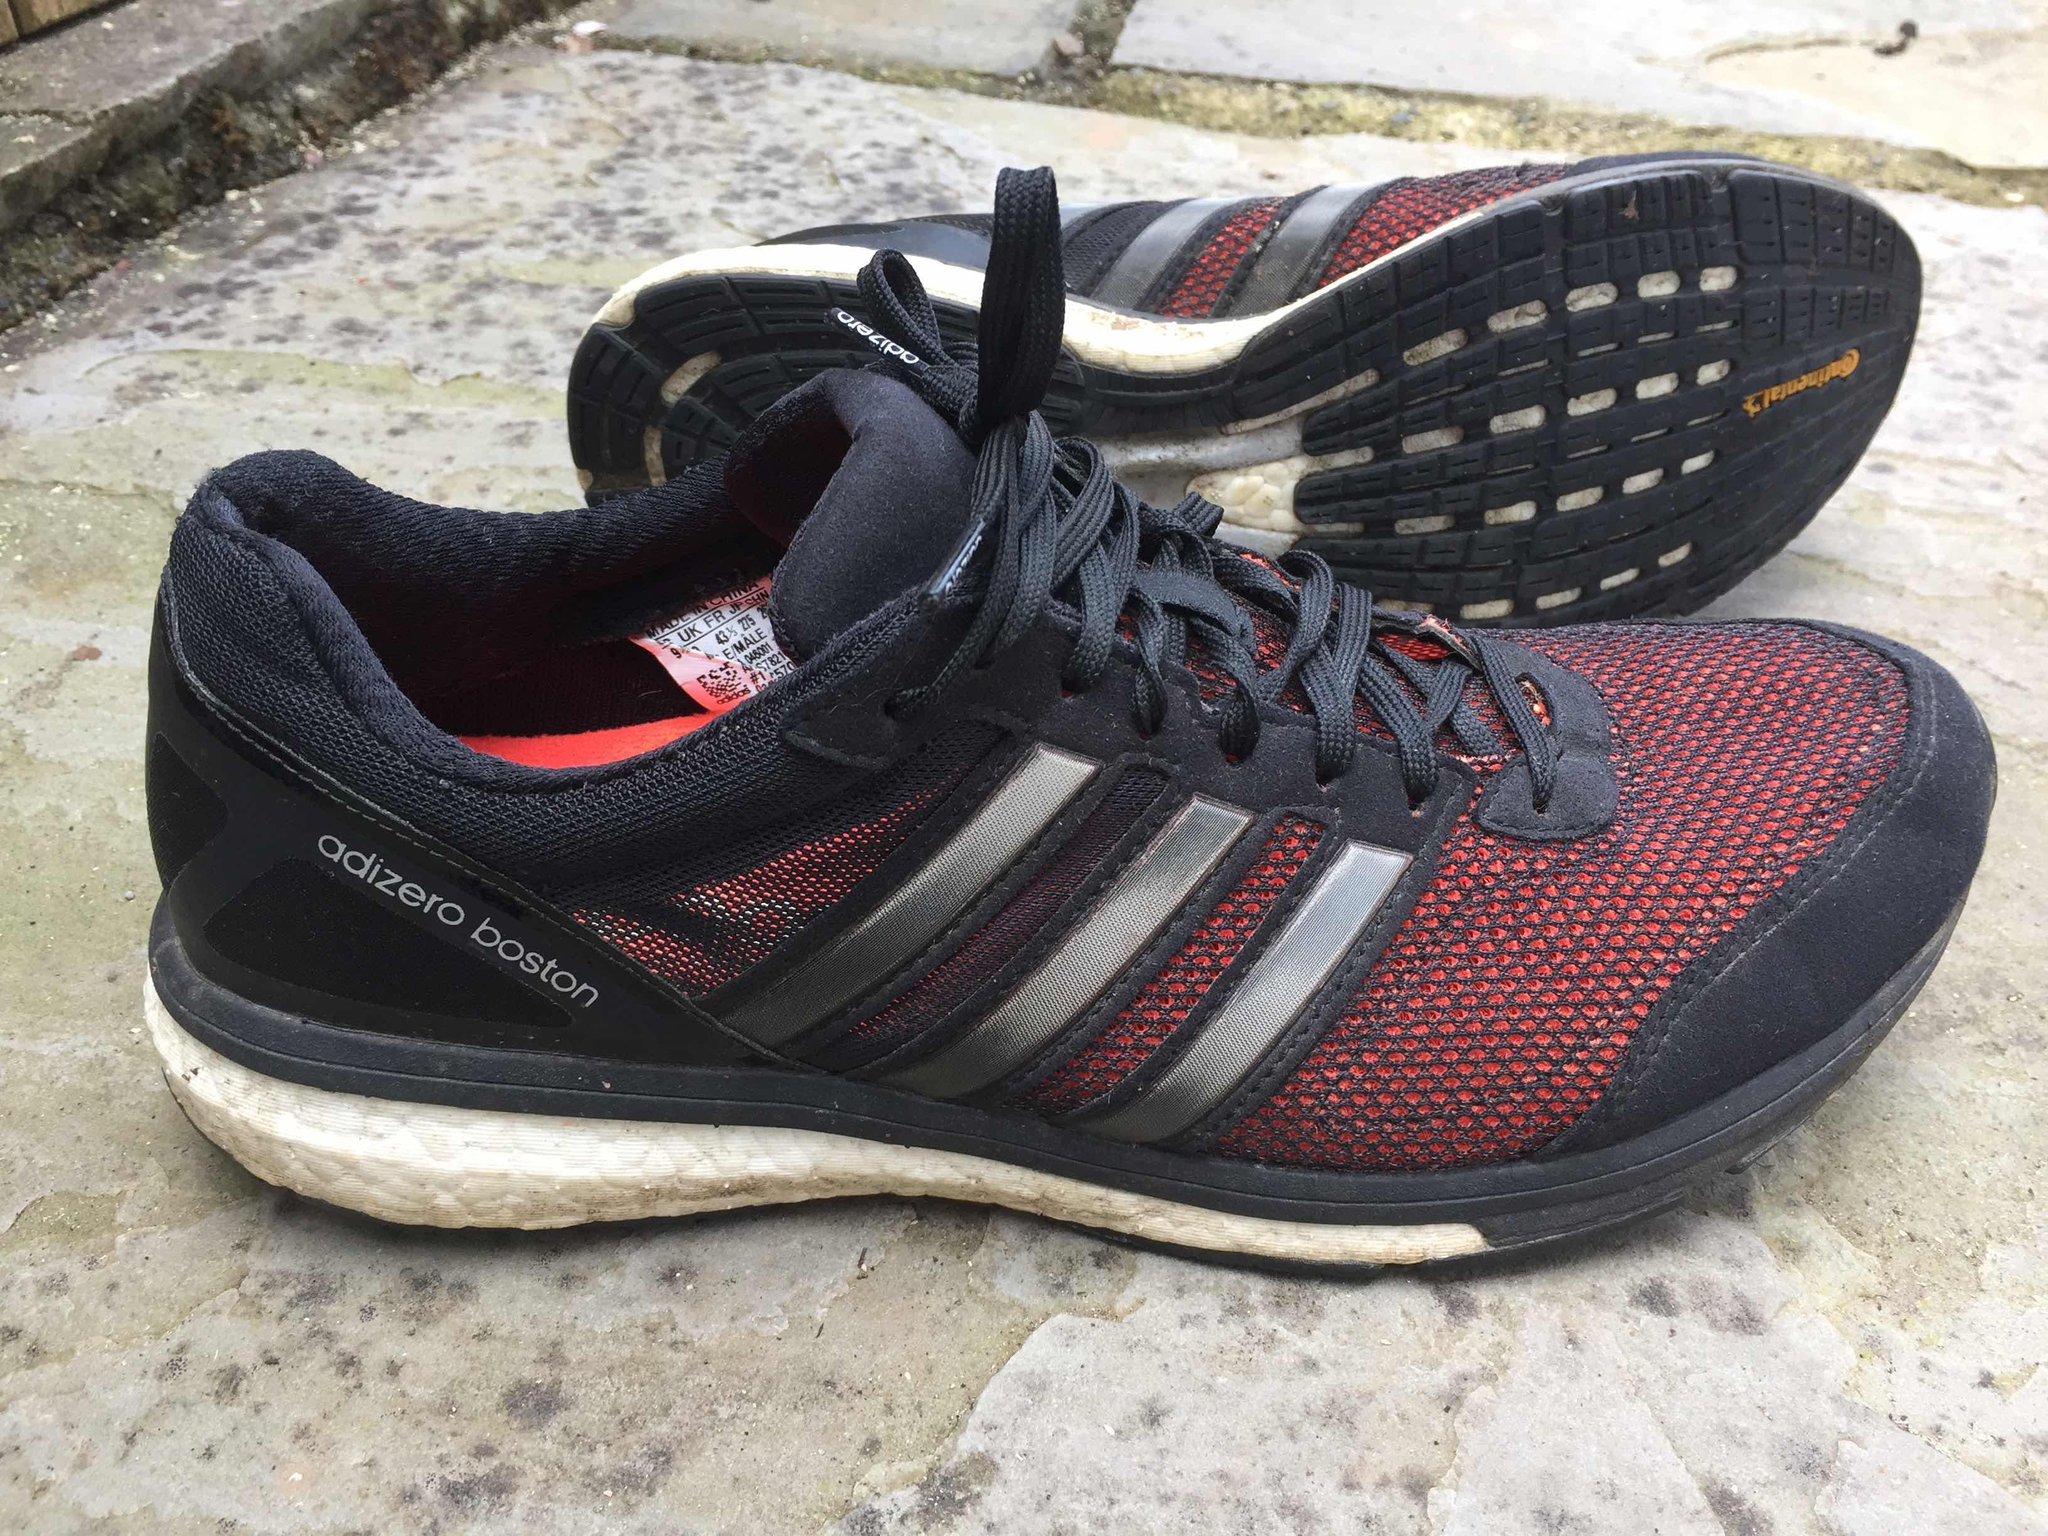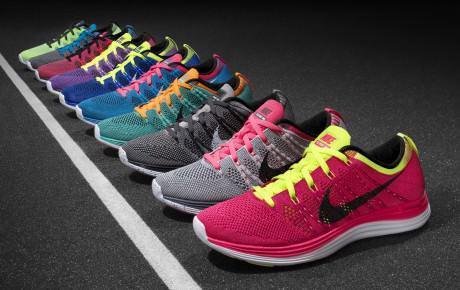The first image is the image on the left, the second image is the image on the right. Assess this claim about the two images: "One image shows only one colorful shoe with matching laces.". Correct or not? Answer yes or no. No. The first image is the image on the left, the second image is the image on the right. Examine the images to the left and right. Is the description "There is exactly one shoe in the image on the left." accurate? Answer yes or no. No. 